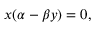<formula> <loc_0><loc_0><loc_500><loc_500>x ( \alpha - \beta y ) = 0 ,</formula> 